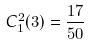<formula> <loc_0><loc_0><loc_500><loc_500>C _ { 1 } ^ { 2 } ( 3 ) = \frac { 1 7 } { 5 0 }</formula> 